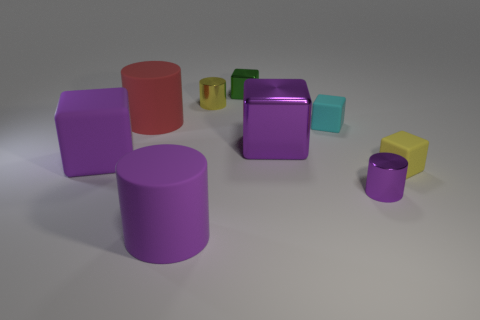Subtract all green blocks. How many blocks are left? 4 Subtract all small green metal cubes. How many cubes are left? 4 Subtract all brown cubes. Subtract all blue spheres. How many cubes are left? 5 Add 1 small gray rubber cylinders. How many objects exist? 10 Subtract all cylinders. How many objects are left? 5 Subtract all tiny blue rubber blocks. Subtract all big purple matte things. How many objects are left? 7 Add 2 big purple matte cylinders. How many big purple matte cylinders are left? 3 Add 5 small yellow metallic things. How many small yellow metallic things exist? 6 Subtract 0 blue cylinders. How many objects are left? 9 